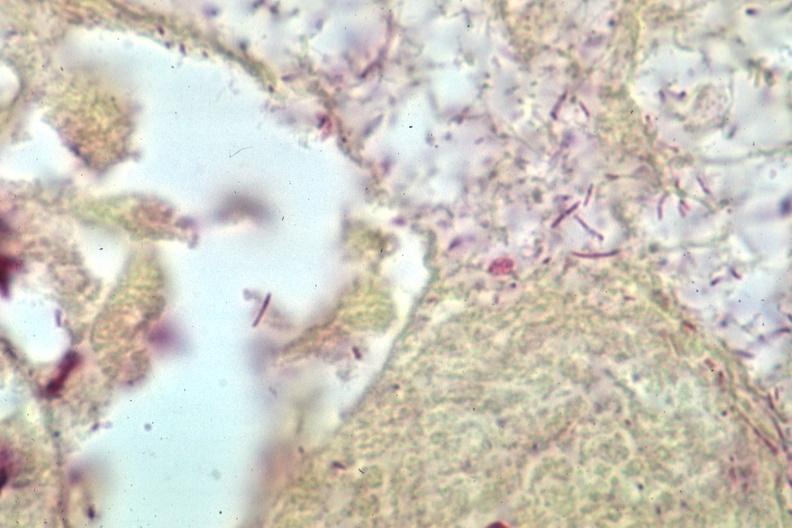s so-called median bar present?
Answer the question using a single word or phrase. No 